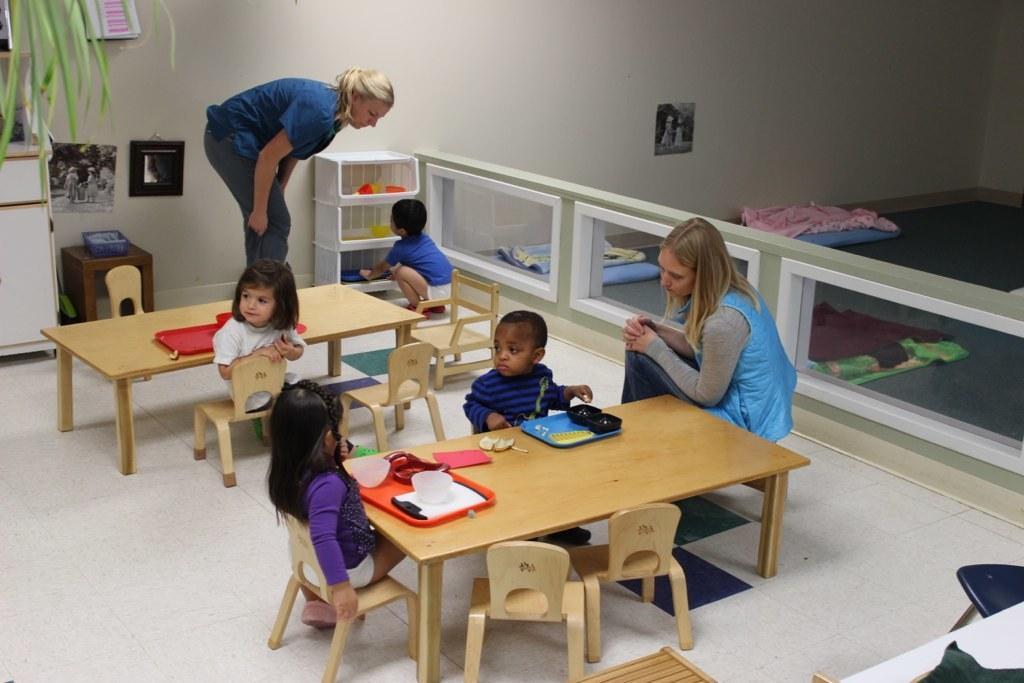How would you summarize this image in a sentence or two? In the center we can see one woman standing and rest of the persons were sitting on the chair around the table. On table we can see some objects. and coming to back we can see wall,shelf,table,cupboard,plant,cloth etc. 